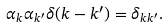<formula> <loc_0><loc_0><loc_500><loc_500>\alpha _ { k } \alpha _ { k ^ { \prime } } \delta ( k - k ^ { \prime } ) = \delta _ { k k ^ { \prime } } .</formula> 